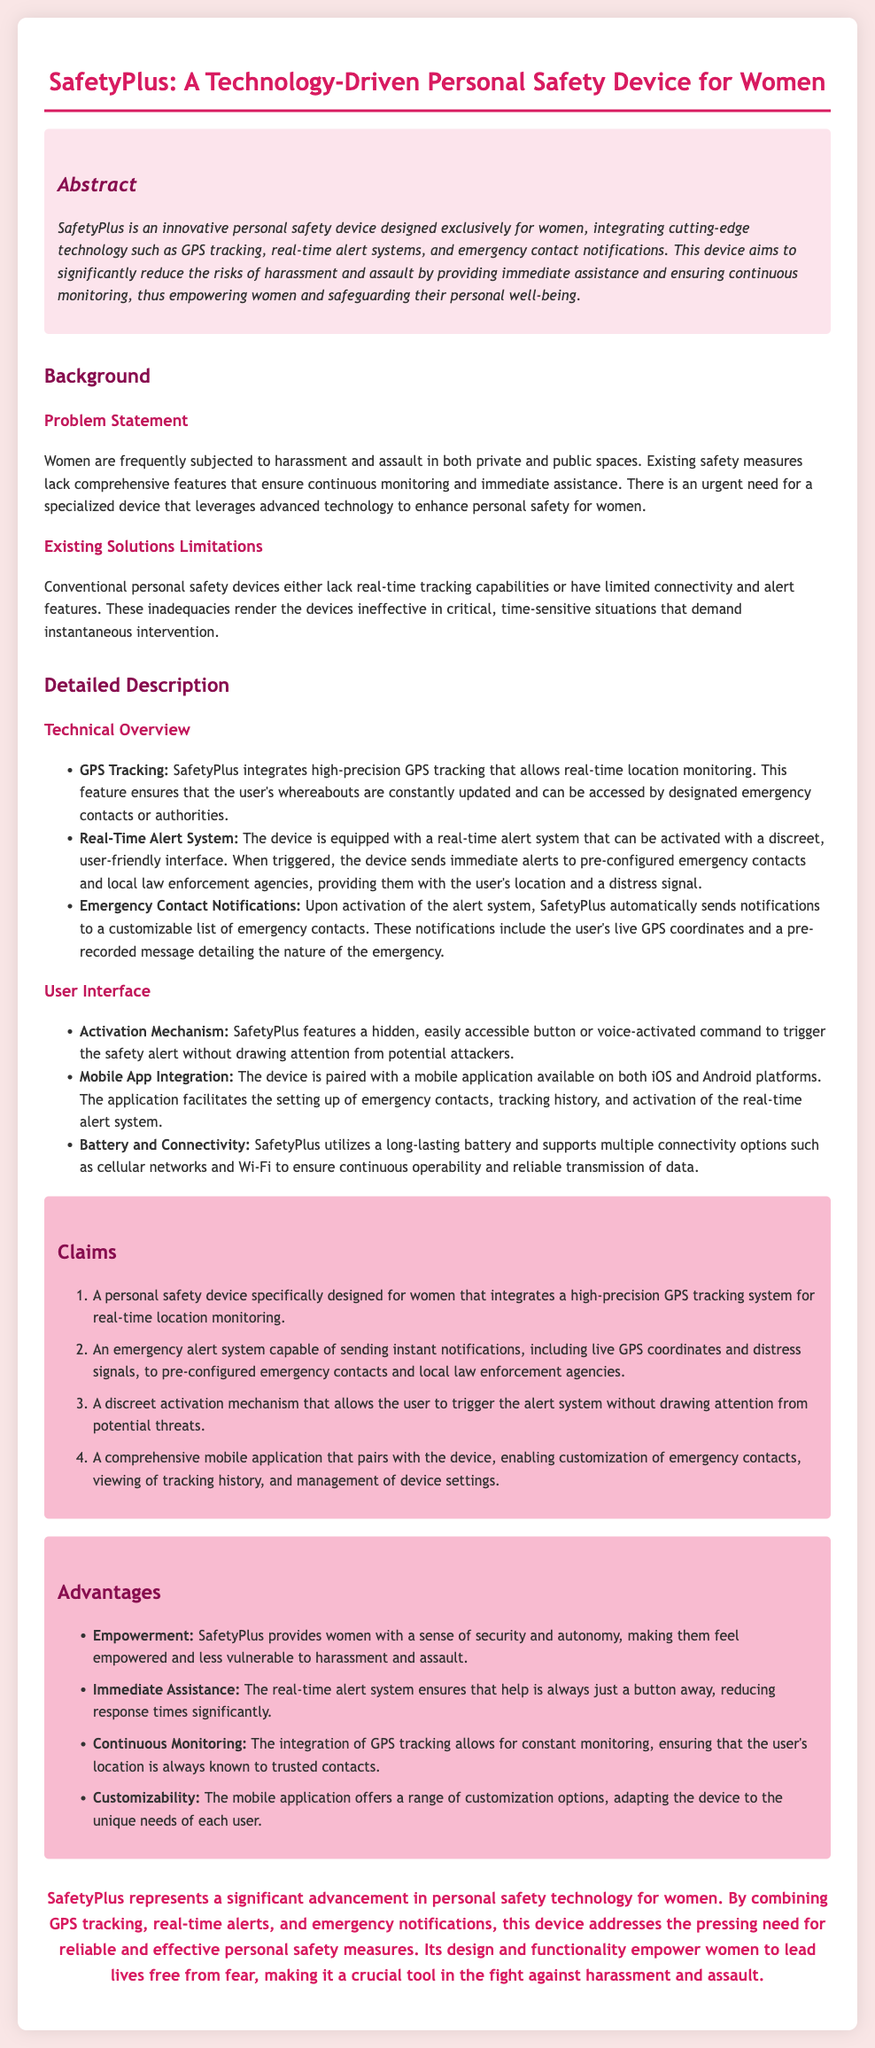What is the name of the device? The device is referred to as SafetyPlus in the document.
Answer: SafetyPlus What feature allows real-time location monitoring? The GPS tracking feature enables real-time location monitoring.
Answer: GPS Tracking How does the device send alerts? The device sends immediate alerts to pre-configured emergency contacts and local law enforcement agencies.
Answer: Emergency alert system What color is used for headings in the document? The headings are in shades of pink and purple, specifically #d81b60, #880e4f, and #c2185b.
Answer: Pink and Purple What is one of the disadvantages of existing solutions mentioned? Conventional personal safety devices lack real-time tracking capabilities.
Answer: Lack of real-time tracking How many claims does the patent application make? The patent application outlines four claims regarding the device.
Answer: Four What provides a user-friendly activation mechanism? The device features a hidden button or voice-activated command for activation.
Answer: Hidden button or voice-activated command What is the primary target demographic for SafetyPlus? The primary target demographic for SafetyPlus is women, as highlighted in the document.
Answer: Women 